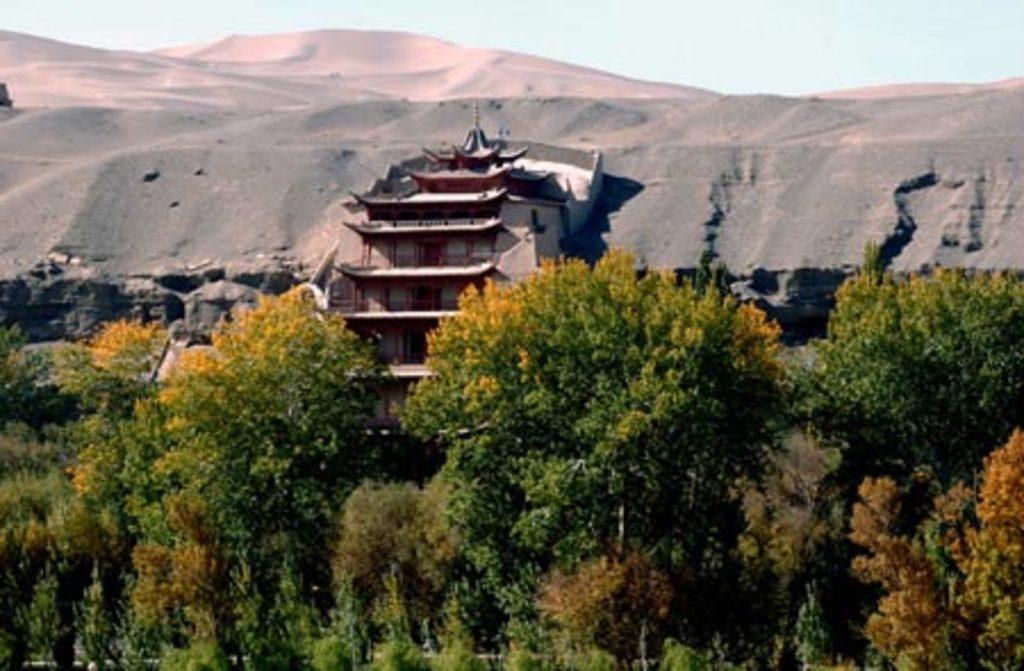How would you summarize this image in a sentence or two? In this image we can see some trees and in the background of the image we can see building there are some mountains, clear sky. 